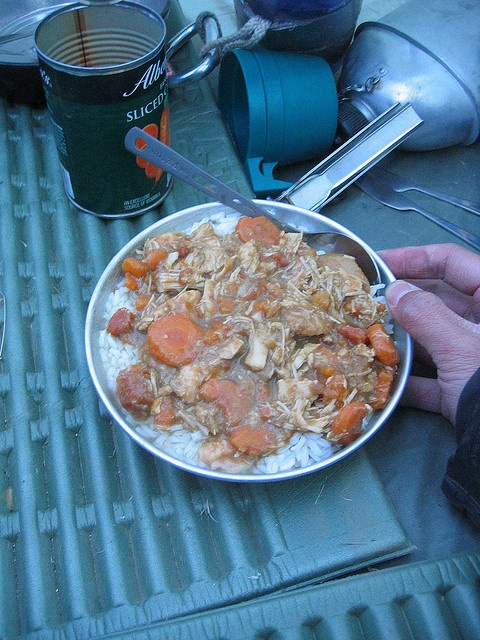Describe the objects in this image and their specific colors. I can see bowl in blue, darkgray, gray, and lightgray tones, cup in blue, black, and gray tones, people in blue, black, gray, purple, and violet tones, cup in blue, teal, black, and darkblue tones, and spoon in blue and gray tones in this image. 